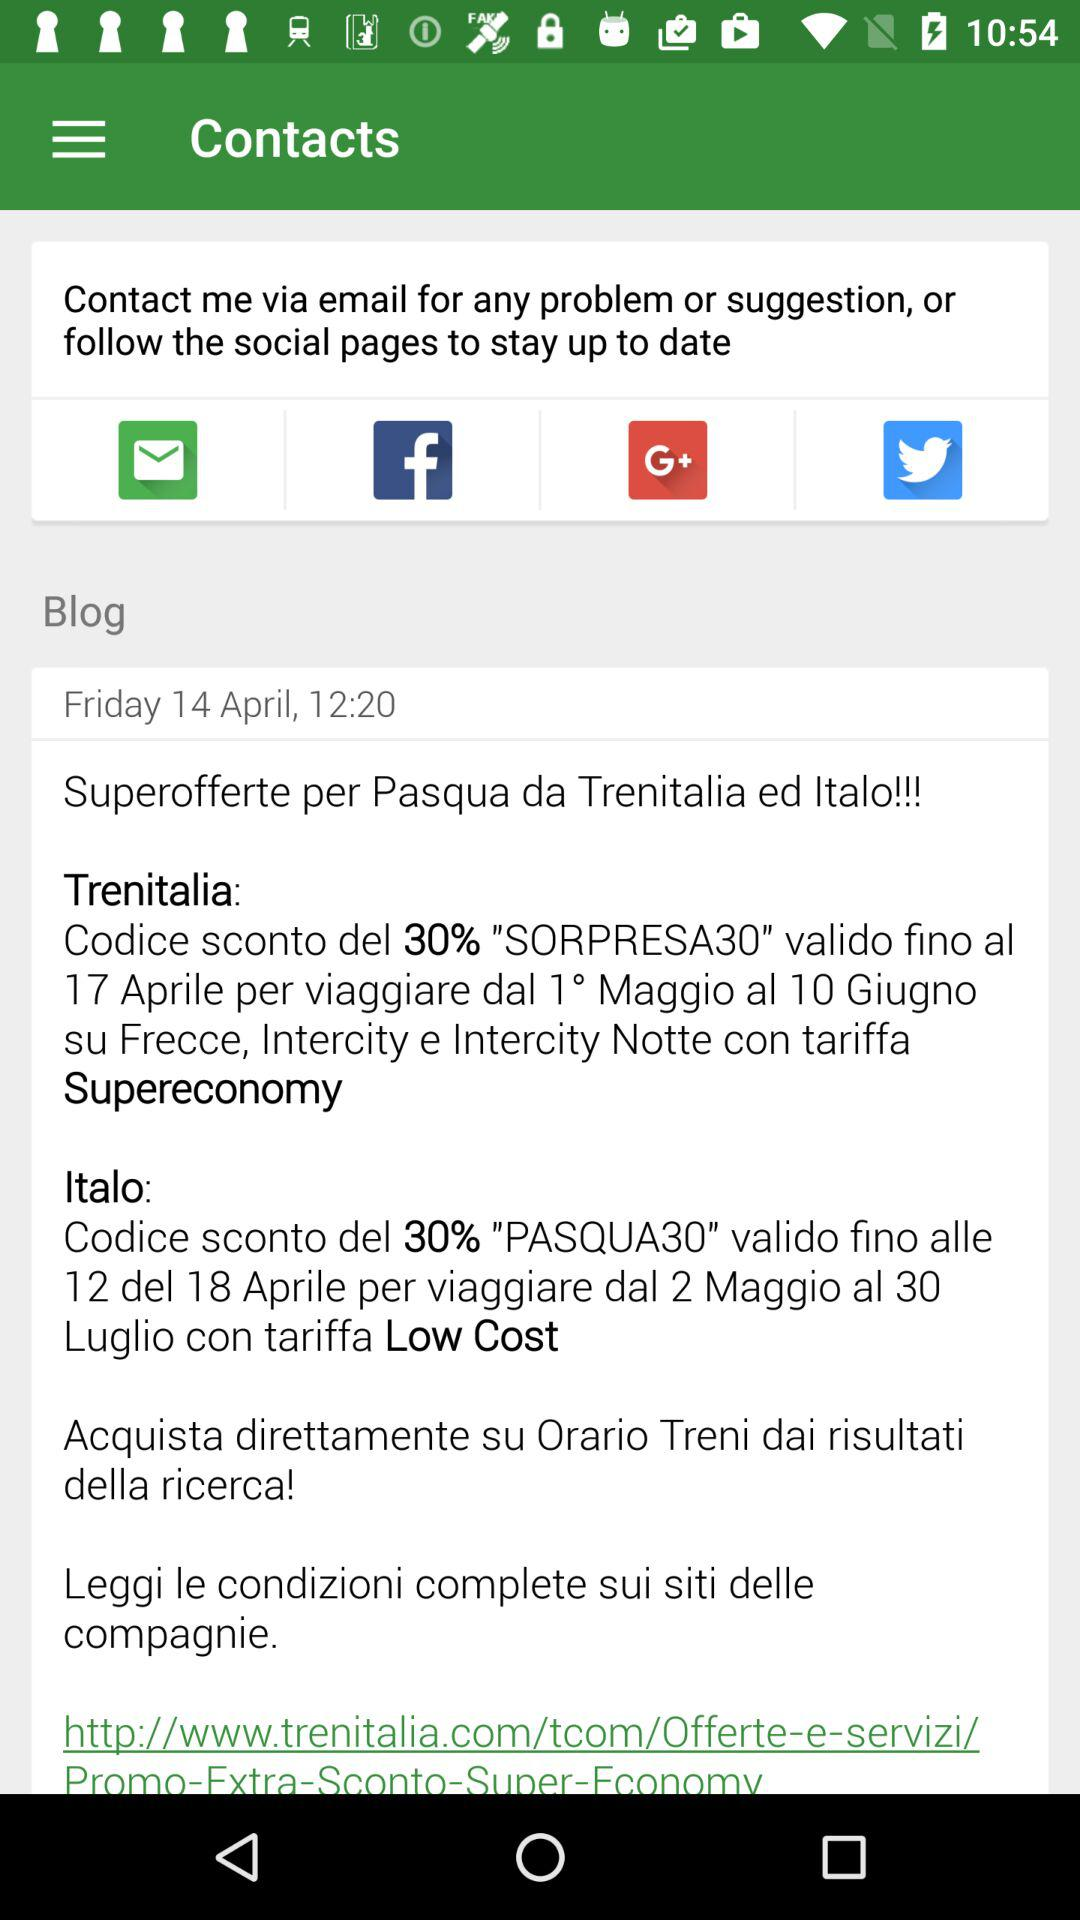Which applications are available for contact?
When the provided information is insufficient, respond with <no answer>. <no answer> 